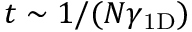<formula> <loc_0><loc_0><loc_500><loc_500>t \sim 1 / ( N \gamma _ { 1 D } )</formula> 